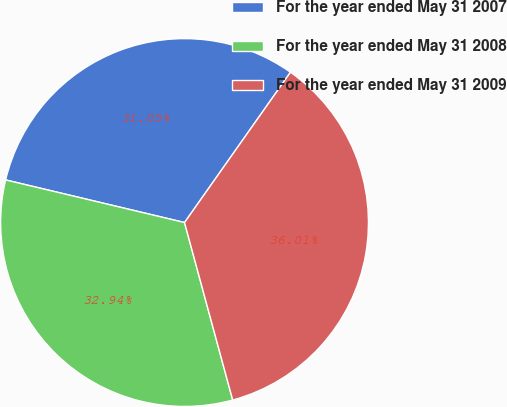<chart> <loc_0><loc_0><loc_500><loc_500><pie_chart><fcel>For the year ended May 31 2007<fcel>For the year ended May 31 2008<fcel>For the year ended May 31 2009<nl><fcel>31.05%<fcel>32.94%<fcel>36.01%<nl></chart> 